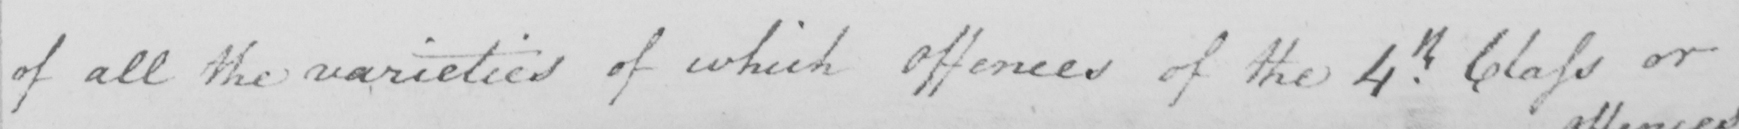Can you read and transcribe this handwriting? of all the varieties of which Offences of the 4.th Class or 